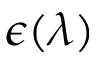<formula> <loc_0><loc_0><loc_500><loc_500>\epsilon ( \lambda )</formula> 